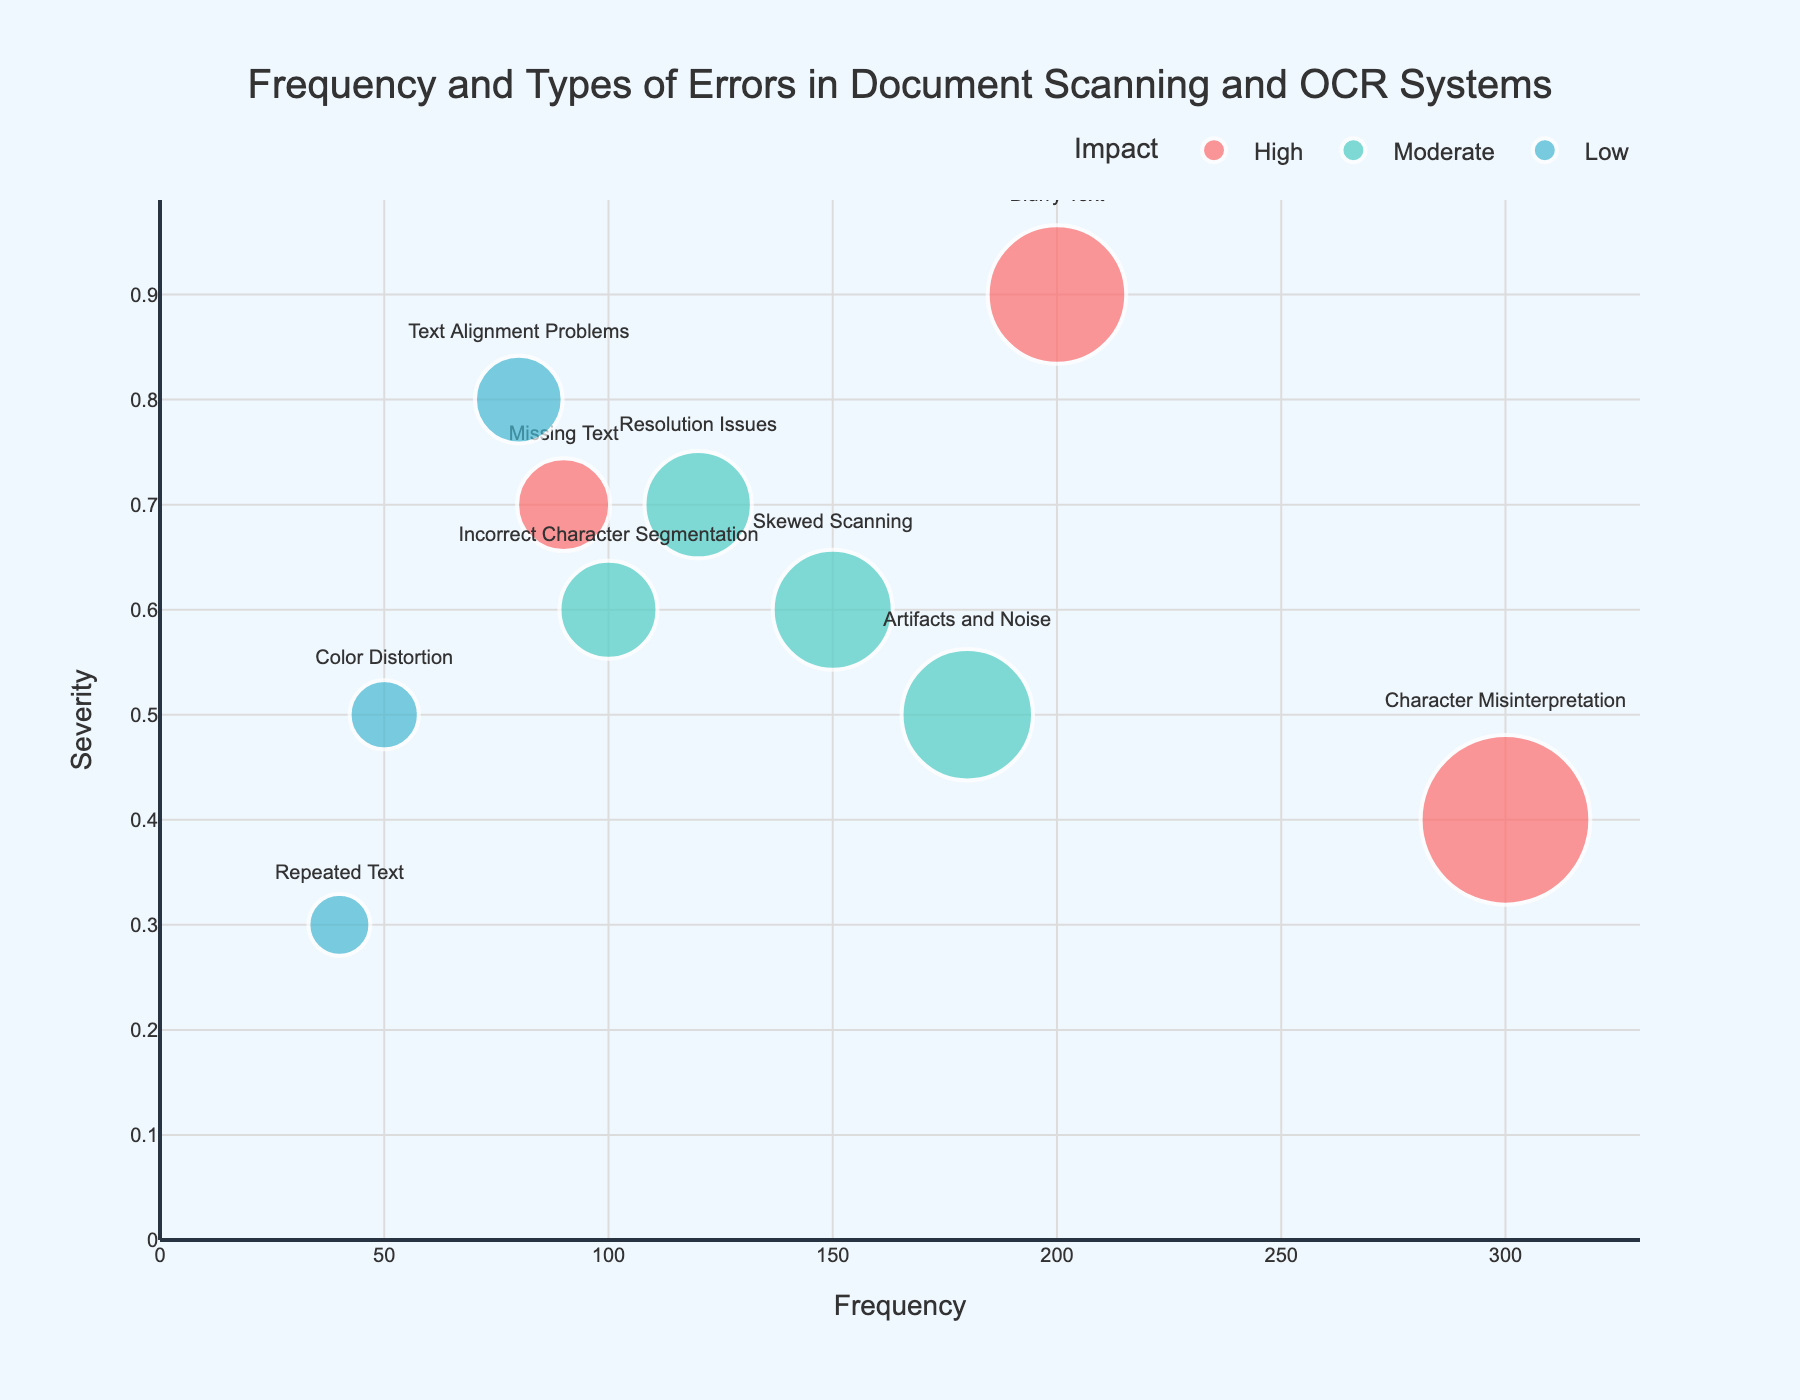what type of error has the highest frequency? Look for the bubble with the largest size horizontally. The x-axis represents frequency, so the bubble farthest to the right indicates the highest frequency. This is "Character Misinterpretation".
Answer: Character Misinterpretation what is the severity of "Blurry Text"? Find the bubble labeled "Blurry Text" and check its position on the y-axis, which represents severity. The bubble is at 0.9, indicating high severity.
Answer: 0.9 which errors have an impact level of 'High'? Identify the bubbles colored distinctly, as the color for "High" is specific in the legend. The errors with 'High' impact include "Character Misinterpretation," "Blurry Text," and "Missing Text".
Answer: Character Misinterpretation, Blurry Text, Missing Text how does the frequency of "Color Distortion" compare to "Artifacts and Noise"? Find both bubbles and compare their positions on the x-axis. "Artifacts and Noise" has a frequency of 180, which is greater than the 50 frequency of "Color Distortion".
Answer: Artifacts and Noise has higher frequency what error has the lowest severity? Check the y-axis for the bubble positioned the lowest. "Repeated Text" is the error with the lowest severity at 0.3.
Answer: Repeated Text which error has the third highest frequency? Rank the bubbles according to their x-axis positions. The third bubble from the right, after "Character Misinterpretation" and "Blurry Text", is "Skewed Scanning".
Answer: Skewed Scanning what is the bubble color associated with moderate impact? Refer to the legend for 'Moderate' and identify the corresponding color, which is a specific shade of green.
Answer: Green what is the total frequency for errors with 'Low' impact? Sum the frequencies of all bubbles colored for 'Low' impact: "Text Alignment Problems", "Color Distortion", and "Repeated Text" have frequencies of 80, 50, and 40, respectively. The total is 80 + 50 + 40 = 170.
Answer: 170 compare the severity of "Incorrect Character Segmentation" and "Skewed Scanning". Which is higher? Locate both bubbles and compare their y-axis positions. "Incorrect Character Segmentation" has a severity of 0.6, while "Skewed Scanning" has the same severity of 0.6. They are equal.
Answer: They are equal 